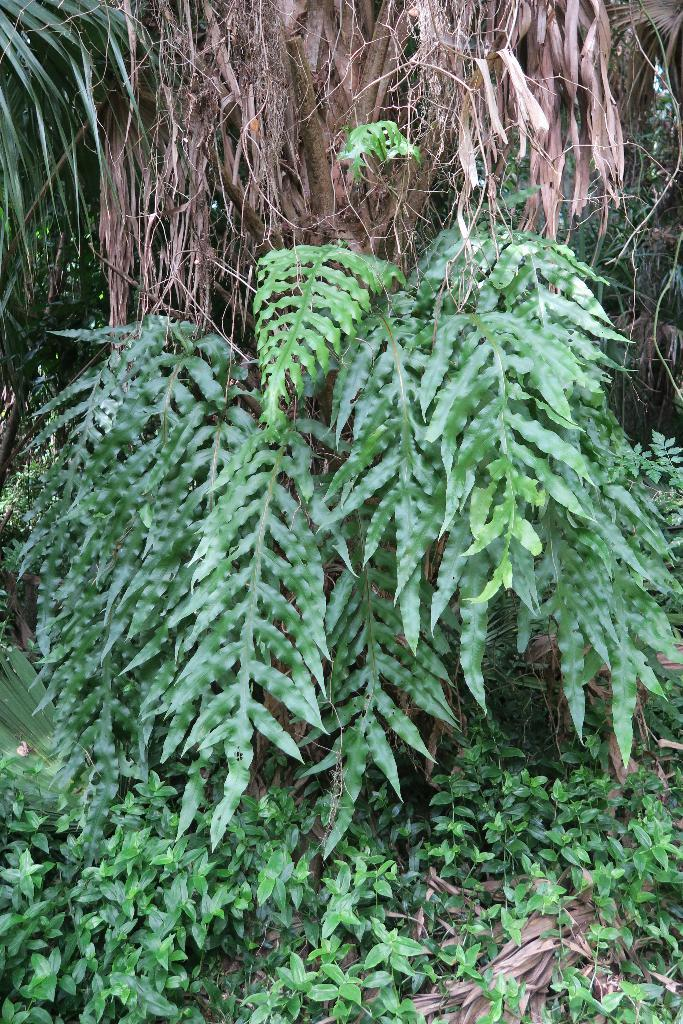What type of living organisms can be seen in the image? Plants can be seen in the image. What is the condition of some of the leaves on the plants? There are dried leaves in the image. What type of clouds can be seen in the image? There are no clouds present in the image; it only features plants and dried leaves. 